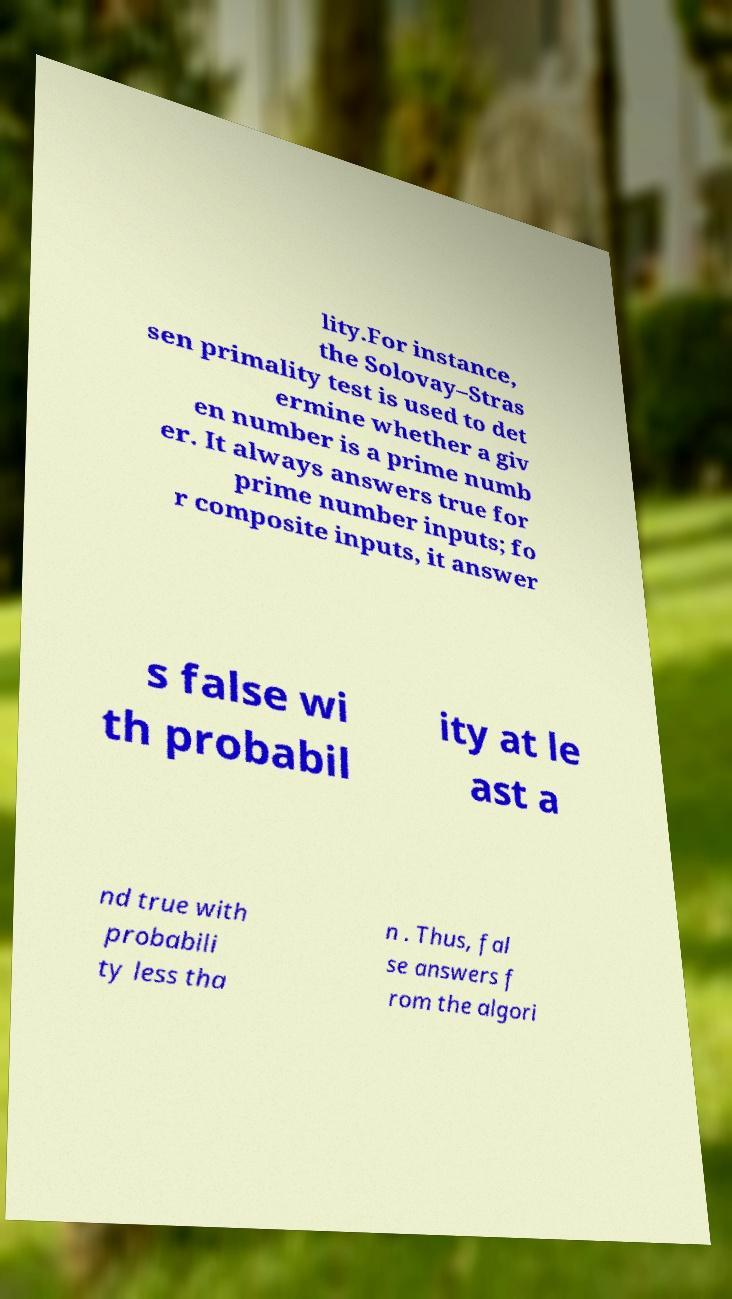Please identify and transcribe the text found in this image. lity.For instance, the Solovay–Stras sen primality test is used to det ermine whether a giv en number is a prime numb er. It always answers true for prime number inputs; fo r composite inputs, it answer s false wi th probabil ity at le ast a nd true with probabili ty less tha n . Thus, fal se answers f rom the algori 